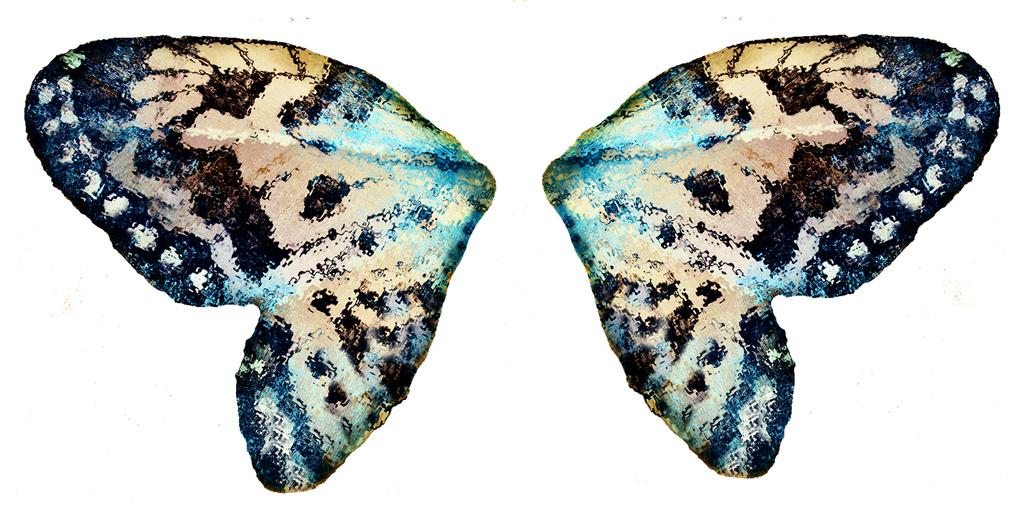What is the main subject of the image? The main subject of the image is two butterfly wings. What color is the background of the image? The background of the image is white. Can you tell if the image was taken during the day or night? The image was likely taken during the day, as there is no indication of darkness or artificial lighting. What type of rod is being used to lift the butterfly wings in the image? There is no rod or lifting action present in the image; it simply shows two butterfly wings. 